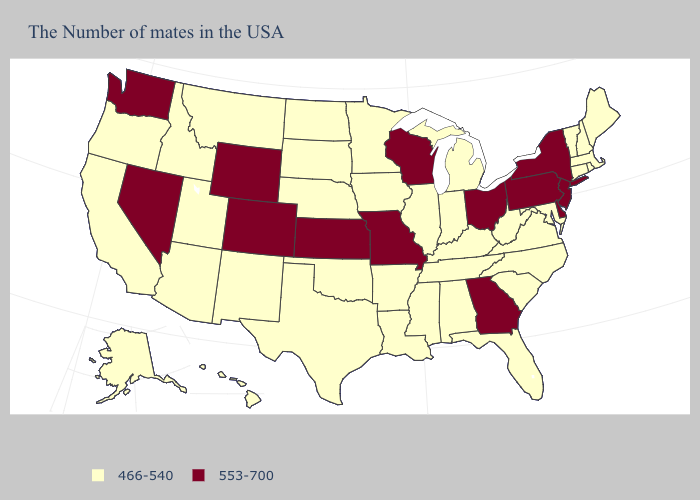Among the states that border Utah , does Colorado have the lowest value?
Short answer required. No. Does Kansas have the lowest value in the MidWest?
Be succinct. No. Does Pennsylvania have the highest value in the USA?
Answer briefly. Yes. What is the highest value in states that border Wyoming?
Answer briefly. 553-700. Is the legend a continuous bar?
Quick response, please. No. What is the highest value in states that border California?
Keep it brief. 553-700. Does Georgia have the highest value in the South?
Quick response, please. Yes. Which states hav the highest value in the MidWest?
Concise answer only. Ohio, Wisconsin, Missouri, Kansas. Does Utah have a higher value than Nebraska?
Be succinct. No. How many symbols are there in the legend?
Quick response, please. 2. Does Michigan have the lowest value in the MidWest?
Keep it brief. Yes. Name the states that have a value in the range 553-700?
Quick response, please. New York, New Jersey, Delaware, Pennsylvania, Ohio, Georgia, Wisconsin, Missouri, Kansas, Wyoming, Colorado, Nevada, Washington. Does North Carolina have the same value as South Carolina?
Quick response, please. Yes. Does Nebraska have a higher value than Illinois?
Keep it brief. No. 